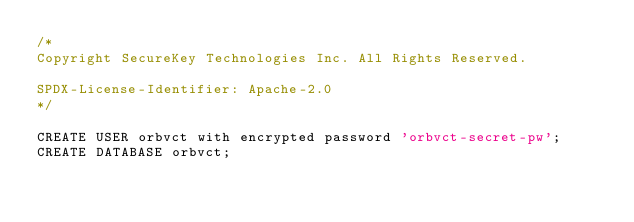<code> <loc_0><loc_0><loc_500><loc_500><_SQL_>/*
Copyright SecureKey Technologies Inc. All Rights Reserved.

SPDX-License-Identifier: Apache-2.0
*/

CREATE USER orbvct with encrypted password 'orbvct-secret-pw';
CREATE DATABASE orbvct;
</code> 